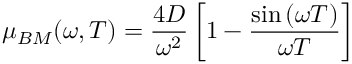<formula> <loc_0><loc_0><loc_500><loc_500>\mu _ { B M } ( \omega , T ) = { \frac { 4 D } { \omega ^ { 2 } } } \left [ 1 - { \frac { \sin \left ( \omega T \right ) } { \omega T } } \right ]</formula> 